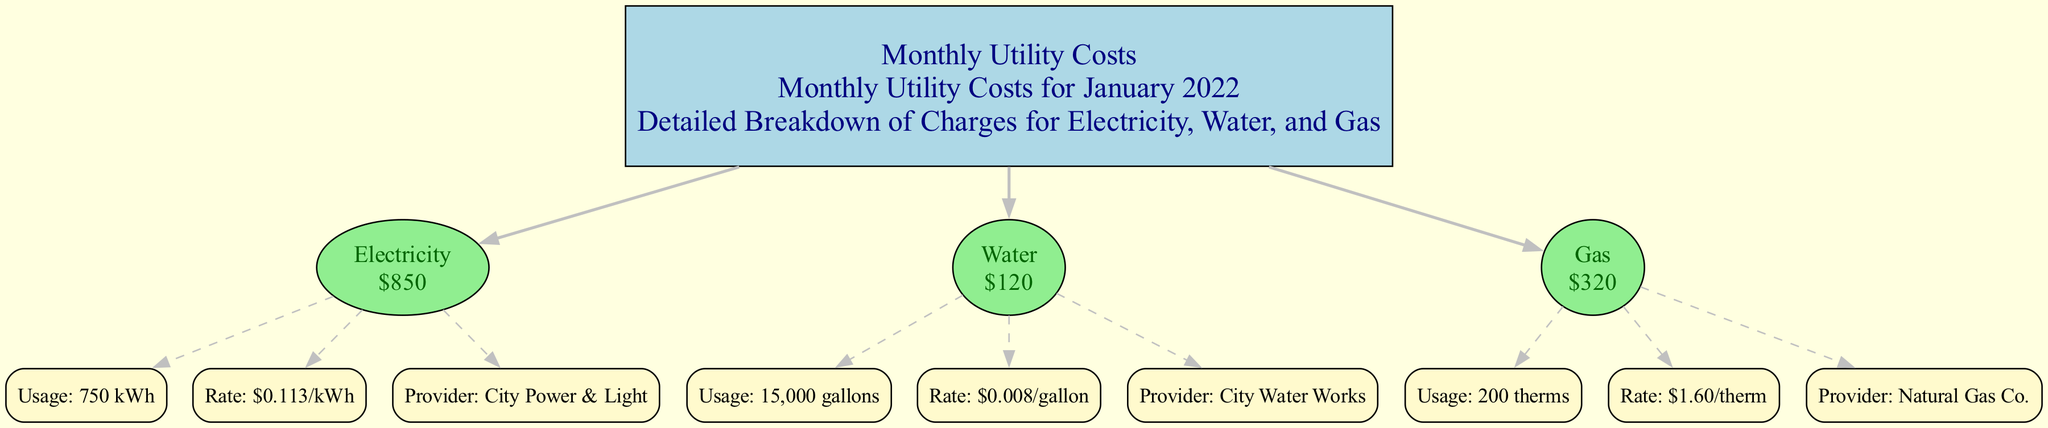What is the total cost for electricity? The diagram shows that the cost listed for electricity is $850, which directly corresponds to the "Electricity" node.
Answer: $850 How much water was consumed in January 2022? According to the details under the "Water" node, the usage is specified as 15,000 gallons.
Answer: 15,000 gallons What is the rate per therm for gas? The "Gas" node indicates that the rate is $1.60 per therm, which is detailed in the node's information.
Answer: $1.60/therm How many utility nodes are shown in the diagram? The diagram consists of three utility nodes: Electricity, Water, and Gas, which can be counted from the main node.
Answer: 3 Which provider supplies the electricity? The "Electricity" node clearly states the provider as "City Power & Light," which is part of the detailed information for that utility.
Answer: City Power & Light What is the total monthly cost for all three utilities combined? To find the total, we add $850 for Electricity, $120 for Water, and $320 for Gas, which results in a total of $1290.
Answer: $1290 What is the usage of water in gallons? The water usage, represented in the "Water" node details, is 15,000 gallons, specifically mentioned beneath usage.
Answer: 15,000 gallons How does the gas usage relate to the total cost? The gas usage of 200 therms, when multiplied by the rate of $1.60 per therm, explains the total gas cost of $320 indicated in the "Gas" node.
Answer: $320 What type of node is used for the main utility cost? The main utility cost is represented as a rectangle, as indicated by the shape specification in the diagram.
Answer: Rectangle 